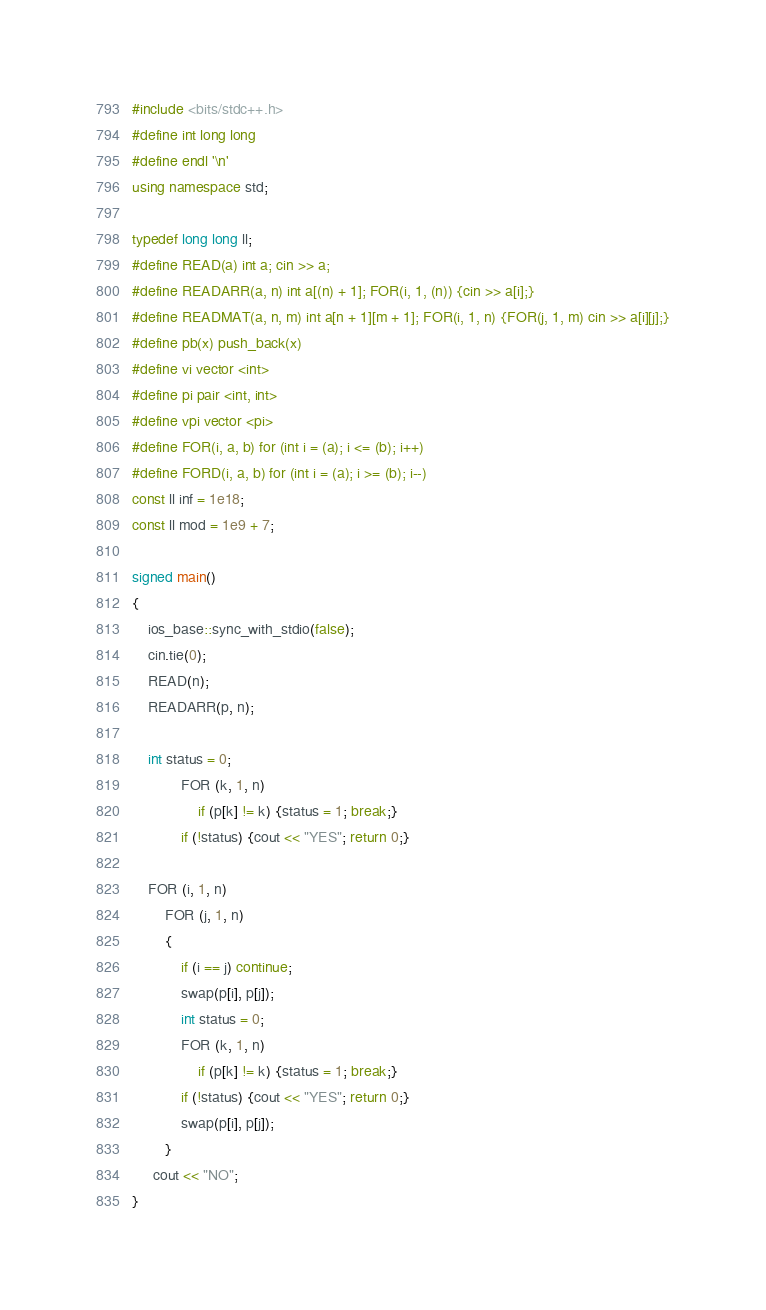<code> <loc_0><loc_0><loc_500><loc_500><_C++_>#include <bits/stdc++.h>
#define int long long
#define endl '\n'
using namespace std;

typedef long long ll;
#define READ(a) int a; cin >> a;
#define READARR(a, n) int a[(n) + 1]; FOR(i, 1, (n)) {cin >> a[i];}
#define READMAT(a, n, m) int a[n + 1][m + 1]; FOR(i, 1, n) {FOR(j, 1, m) cin >> a[i][j];}
#define pb(x) push_back(x)
#define vi vector <int>
#define pi pair <int, int>
#define vpi vector <pi>
#define FOR(i, a, b) for (int i = (a); i <= (b); i++)
#define FORD(i, a, b) for (int i = (a); i >= (b); i--)
const ll inf = 1e18;
const ll mod = 1e9 + 7;

signed main()
{
	ios_base::sync_with_stdio(false);
	cin.tie(0);
	READ(n);
	READARR(p, n);
	
	int status = 0;
	        FOR (k, 1, n)
	            if (p[k] != k) {status = 1; break;}
	        if (!status) {cout << "YES"; return 0;}
	
	FOR (i, 1, n)
	    FOR (j, 1, n)
	    {
	        if (i == j) continue;
	        swap(p[i], p[j]);
	        int status = 0;
	        FOR (k, 1, n)
	            if (p[k] != k) {status = 1; break;}
	        if (!status) {cout << "YES"; return 0;}
	        swap(p[i], p[j]);
	    }
	 cout << "NO";
}</code> 